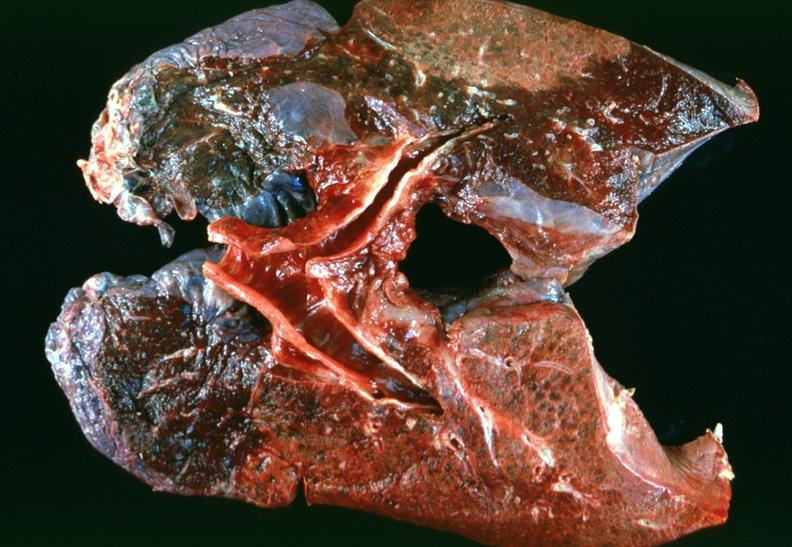does this image show lung, emphysema severe with bullae?
Answer the question using a single word or phrase. Yes 